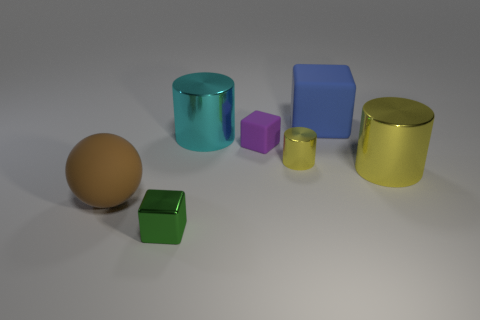There is a brown rubber object; is its size the same as the rubber object that is behind the large cyan cylinder? The brown rubber object appears to be slightly larger in comparison to the smaller rubber object placed behind the large cyan cylinder, when taking perspective into account. 